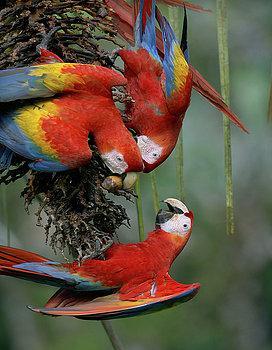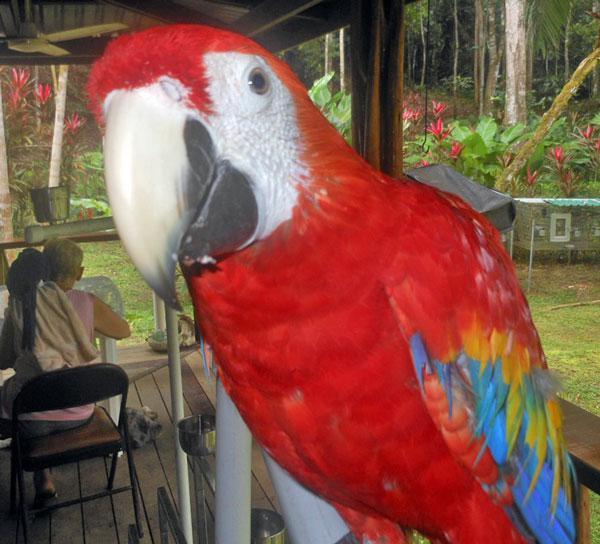The first image is the image on the left, the second image is the image on the right. Assess this claim about the two images: "There are no more than 2 birds in each image.". Correct or not? Answer yes or no. No. 